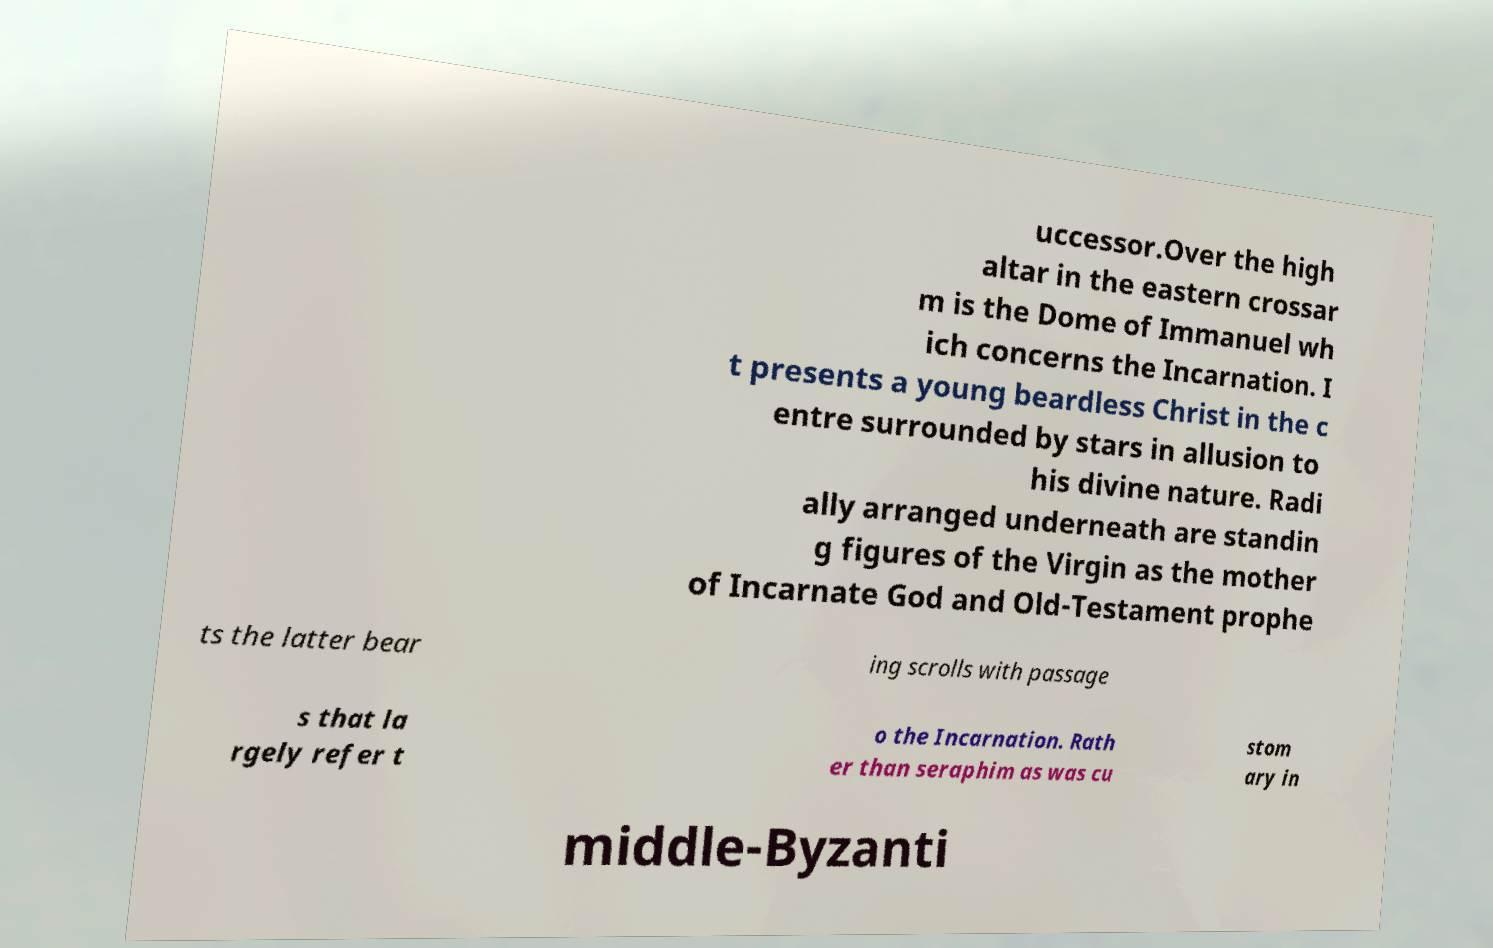Could you extract and type out the text from this image? uccessor.Over the high altar in the eastern crossar m is the Dome of Immanuel wh ich concerns the Incarnation. I t presents a young beardless Christ in the c entre surrounded by stars in allusion to his divine nature. Radi ally arranged underneath are standin g figures of the Virgin as the mother of Incarnate God and Old-Testament prophe ts the latter bear ing scrolls with passage s that la rgely refer t o the Incarnation. Rath er than seraphim as was cu stom ary in middle-Byzanti 